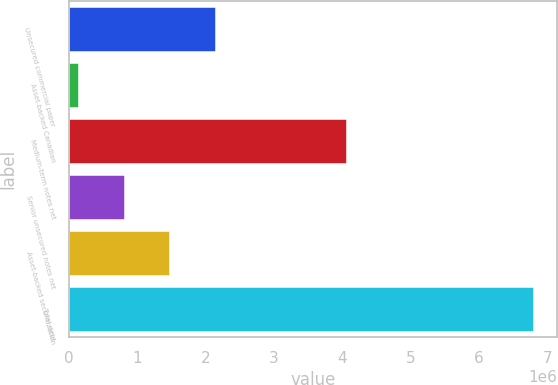Convert chart. <chart><loc_0><loc_0><loc_500><loc_500><bar_chart><fcel>Unsecured commercial paper<fcel>Asset-backed Canadian<fcel>Medium-term notes net<fcel>Senior unsecured notes net<fcel>Asset-backed securitization<fcel>Total debt<nl><fcel>2.14681e+06<fcel>149338<fcel>4.06494e+06<fcel>815161<fcel>1.48098e+06<fcel>6.80757e+06<nl></chart> 